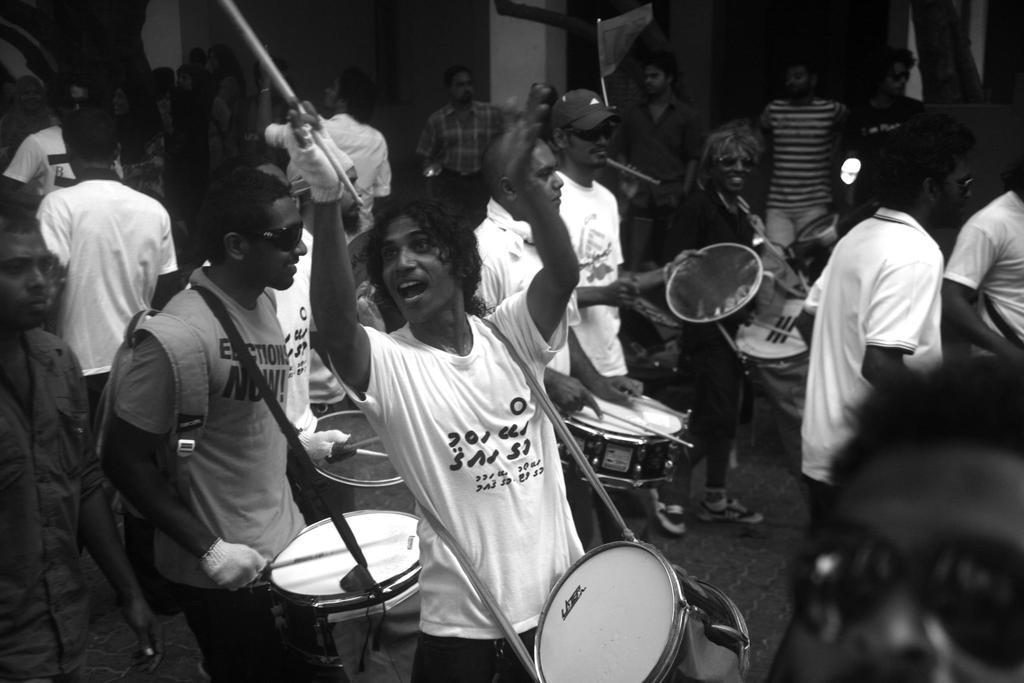Could you give a brief overview of what you see in this image? Many persons are playing musical instruments. In the front a person is holding a drumstick and he is having a gloves and drums. Behind him another person is wearing a bag. 